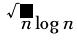Convert formula to latex. <formula><loc_0><loc_0><loc_500><loc_500>\sqrt { n } \log n</formula> 